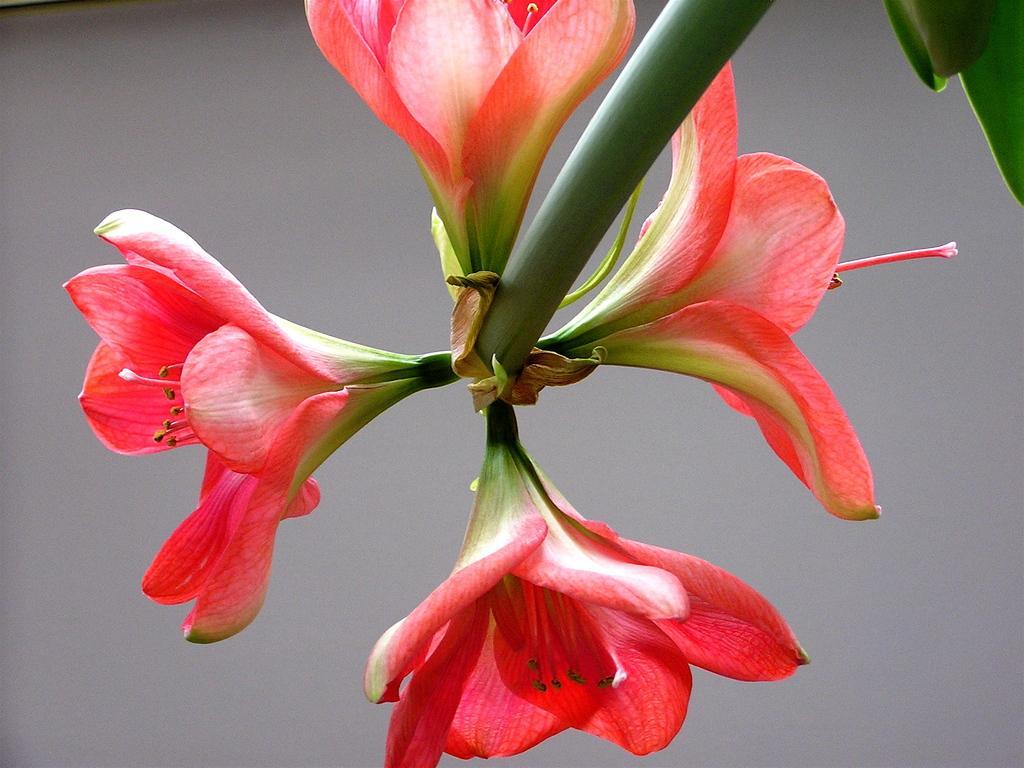How would you summarize this image in a sentence or two? In this image, we can see a flower. We can also see some leaves on the top right corner. We can also see the background. 